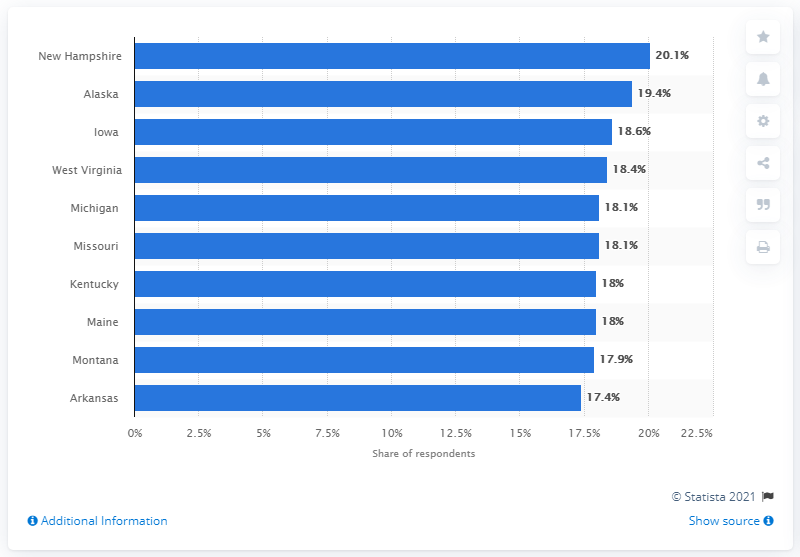Point out several critical features in this image. In the past 12 months, approximately 20.1% of high school students in New Hampshire reported being bullied electronically, according to a recent study. 